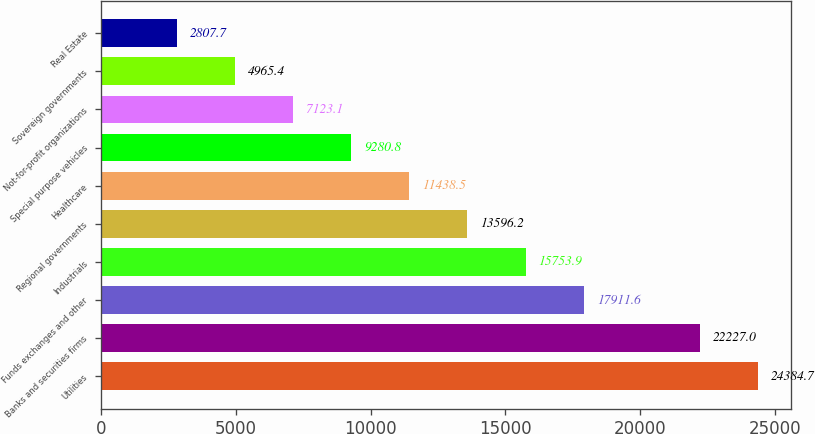<chart> <loc_0><loc_0><loc_500><loc_500><bar_chart><fcel>Utilities<fcel>Banks and securities firms<fcel>Funds exchanges and other<fcel>Industrials<fcel>Regional governments<fcel>Healthcare<fcel>Special purpose vehicles<fcel>Not-for-profit organizations<fcel>Sovereign governments<fcel>Real Estate<nl><fcel>24384.7<fcel>22227<fcel>17911.6<fcel>15753.9<fcel>13596.2<fcel>11438.5<fcel>9280.8<fcel>7123.1<fcel>4965.4<fcel>2807.7<nl></chart> 